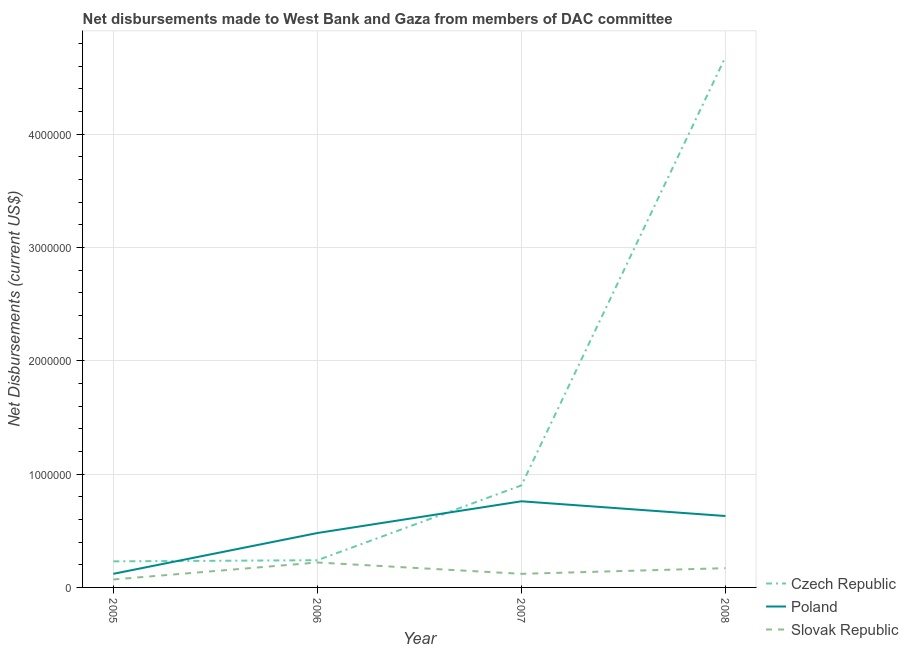How many different coloured lines are there?
Provide a succinct answer. 3. Is the number of lines equal to the number of legend labels?
Your response must be concise. Yes. What is the net disbursements made by slovak republic in 2008?
Offer a terse response. 1.70e+05. Across all years, what is the maximum net disbursements made by czech republic?
Your answer should be compact. 4.68e+06. Across all years, what is the minimum net disbursements made by slovak republic?
Give a very brief answer. 7.00e+04. In which year was the net disbursements made by czech republic maximum?
Provide a short and direct response. 2008. In which year was the net disbursements made by czech republic minimum?
Your response must be concise. 2005. What is the total net disbursements made by poland in the graph?
Provide a short and direct response. 1.99e+06. What is the difference between the net disbursements made by poland in 2005 and that in 2008?
Your answer should be very brief. -5.10e+05. What is the difference between the net disbursements made by slovak republic in 2007 and the net disbursements made by czech republic in 2006?
Ensure brevity in your answer.  -1.20e+05. What is the average net disbursements made by poland per year?
Offer a terse response. 4.98e+05. In the year 2005, what is the difference between the net disbursements made by poland and net disbursements made by slovak republic?
Provide a short and direct response. 5.00e+04. In how many years, is the net disbursements made by poland greater than 4200000 US$?
Your answer should be very brief. 0. What is the ratio of the net disbursements made by slovak republic in 2005 to that in 2008?
Your response must be concise. 0.41. Is the net disbursements made by czech republic in 2006 less than that in 2007?
Your answer should be very brief. Yes. What is the difference between the highest and the second highest net disbursements made by czech republic?
Keep it short and to the point. 3.78e+06. What is the difference between the highest and the lowest net disbursements made by slovak republic?
Make the answer very short. 1.50e+05. In how many years, is the net disbursements made by czech republic greater than the average net disbursements made by czech republic taken over all years?
Your answer should be compact. 1. Is the sum of the net disbursements made by poland in 2005 and 2008 greater than the maximum net disbursements made by slovak republic across all years?
Offer a terse response. Yes. Is it the case that in every year, the sum of the net disbursements made by czech republic and net disbursements made by poland is greater than the net disbursements made by slovak republic?
Your answer should be compact. Yes. How many lines are there?
Your response must be concise. 3. What is the difference between two consecutive major ticks on the Y-axis?
Keep it short and to the point. 1.00e+06. Are the values on the major ticks of Y-axis written in scientific E-notation?
Make the answer very short. No. Does the graph contain any zero values?
Offer a terse response. No. Where does the legend appear in the graph?
Your response must be concise. Bottom right. What is the title of the graph?
Your response must be concise. Net disbursements made to West Bank and Gaza from members of DAC committee. What is the label or title of the Y-axis?
Give a very brief answer. Net Disbursements (current US$). What is the Net Disbursements (current US$) in Slovak Republic in 2006?
Ensure brevity in your answer.  2.20e+05. What is the Net Disbursements (current US$) in Czech Republic in 2007?
Offer a very short reply. 9.00e+05. What is the Net Disbursements (current US$) of Poland in 2007?
Offer a very short reply. 7.60e+05. What is the Net Disbursements (current US$) of Slovak Republic in 2007?
Your answer should be compact. 1.20e+05. What is the Net Disbursements (current US$) of Czech Republic in 2008?
Give a very brief answer. 4.68e+06. What is the Net Disbursements (current US$) of Poland in 2008?
Keep it short and to the point. 6.30e+05. Across all years, what is the maximum Net Disbursements (current US$) in Czech Republic?
Provide a short and direct response. 4.68e+06. Across all years, what is the maximum Net Disbursements (current US$) of Poland?
Keep it short and to the point. 7.60e+05. Across all years, what is the maximum Net Disbursements (current US$) in Slovak Republic?
Offer a terse response. 2.20e+05. Across all years, what is the minimum Net Disbursements (current US$) in Czech Republic?
Your answer should be compact. 2.30e+05. Across all years, what is the minimum Net Disbursements (current US$) in Poland?
Offer a terse response. 1.20e+05. What is the total Net Disbursements (current US$) in Czech Republic in the graph?
Make the answer very short. 6.05e+06. What is the total Net Disbursements (current US$) of Poland in the graph?
Your answer should be very brief. 1.99e+06. What is the total Net Disbursements (current US$) in Slovak Republic in the graph?
Keep it short and to the point. 5.80e+05. What is the difference between the Net Disbursements (current US$) in Czech Republic in 2005 and that in 2006?
Keep it short and to the point. -10000. What is the difference between the Net Disbursements (current US$) of Poland in 2005 and that in 2006?
Keep it short and to the point. -3.60e+05. What is the difference between the Net Disbursements (current US$) in Slovak Republic in 2005 and that in 2006?
Provide a succinct answer. -1.50e+05. What is the difference between the Net Disbursements (current US$) in Czech Republic in 2005 and that in 2007?
Offer a very short reply. -6.70e+05. What is the difference between the Net Disbursements (current US$) of Poland in 2005 and that in 2007?
Offer a terse response. -6.40e+05. What is the difference between the Net Disbursements (current US$) in Czech Republic in 2005 and that in 2008?
Your answer should be very brief. -4.45e+06. What is the difference between the Net Disbursements (current US$) of Poland in 2005 and that in 2008?
Offer a terse response. -5.10e+05. What is the difference between the Net Disbursements (current US$) in Slovak Republic in 2005 and that in 2008?
Ensure brevity in your answer.  -1.00e+05. What is the difference between the Net Disbursements (current US$) in Czech Republic in 2006 and that in 2007?
Keep it short and to the point. -6.60e+05. What is the difference between the Net Disbursements (current US$) in Poland in 2006 and that in 2007?
Offer a very short reply. -2.80e+05. What is the difference between the Net Disbursements (current US$) of Slovak Republic in 2006 and that in 2007?
Offer a terse response. 1.00e+05. What is the difference between the Net Disbursements (current US$) in Czech Republic in 2006 and that in 2008?
Your answer should be very brief. -4.44e+06. What is the difference between the Net Disbursements (current US$) in Slovak Republic in 2006 and that in 2008?
Offer a terse response. 5.00e+04. What is the difference between the Net Disbursements (current US$) in Czech Republic in 2007 and that in 2008?
Keep it short and to the point. -3.78e+06. What is the difference between the Net Disbursements (current US$) in Poland in 2007 and that in 2008?
Give a very brief answer. 1.30e+05. What is the difference between the Net Disbursements (current US$) in Slovak Republic in 2007 and that in 2008?
Your response must be concise. -5.00e+04. What is the difference between the Net Disbursements (current US$) of Czech Republic in 2005 and the Net Disbursements (current US$) of Poland in 2007?
Offer a terse response. -5.30e+05. What is the difference between the Net Disbursements (current US$) of Poland in 2005 and the Net Disbursements (current US$) of Slovak Republic in 2007?
Offer a terse response. 0. What is the difference between the Net Disbursements (current US$) in Czech Republic in 2005 and the Net Disbursements (current US$) in Poland in 2008?
Keep it short and to the point. -4.00e+05. What is the difference between the Net Disbursements (current US$) in Poland in 2005 and the Net Disbursements (current US$) in Slovak Republic in 2008?
Provide a succinct answer. -5.00e+04. What is the difference between the Net Disbursements (current US$) of Czech Republic in 2006 and the Net Disbursements (current US$) of Poland in 2007?
Offer a terse response. -5.20e+05. What is the difference between the Net Disbursements (current US$) of Poland in 2006 and the Net Disbursements (current US$) of Slovak Republic in 2007?
Offer a very short reply. 3.60e+05. What is the difference between the Net Disbursements (current US$) in Czech Republic in 2006 and the Net Disbursements (current US$) in Poland in 2008?
Your answer should be very brief. -3.90e+05. What is the difference between the Net Disbursements (current US$) of Czech Republic in 2007 and the Net Disbursements (current US$) of Poland in 2008?
Your answer should be compact. 2.70e+05. What is the difference between the Net Disbursements (current US$) in Czech Republic in 2007 and the Net Disbursements (current US$) in Slovak Republic in 2008?
Provide a succinct answer. 7.30e+05. What is the difference between the Net Disbursements (current US$) of Poland in 2007 and the Net Disbursements (current US$) of Slovak Republic in 2008?
Offer a terse response. 5.90e+05. What is the average Net Disbursements (current US$) in Czech Republic per year?
Offer a very short reply. 1.51e+06. What is the average Net Disbursements (current US$) in Poland per year?
Your answer should be very brief. 4.98e+05. What is the average Net Disbursements (current US$) in Slovak Republic per year?
Offer a terse response. 1.45e+05. In the year 2005, what is the difference between the Net Disbursements (current US$) of Czech Republic and Net Disbursements (current US$) of Slovak Republic?
Give a very brief answer. 1.60e+05. In the year 2006, what is the difference between the Net Disbursements (current US$) in Czech Republic and Net Disbursements (current US$) in Poland?
Make the answer very short. -2.40e+05. In the year 2006, what is the difference between the Net Disbursements (current US$) of Czech Republic and Net Disbursements (current US$) of Slovak Republic?
Make the answer very short. 2.00e+04. In the year 2007, what is the difference between the Net Disbursements (current US$) in Czech Republic and Net Disbursements (current US$) in Slovak Republic?
Offer a very short reply. 7.80e+05. In the year 2007, what is the difference between the Net Disbursements (current US$) of Poland and Net Disbursements (current US$) of Slovak Republic?
Your response must be concise. 6.40e+05. In the year 2008, what is the difference between the Net Disbursements (current US$) of Czech Republic and Net Disbursements (current US$) of Poland?
Make the answer very short. 4.05e+06. In the year 2008, what is the difference between the Net Disbursements (current US$) in Czech Republic and Net Disbursements (current US$) in Slovak Republic?
Offer a terse response. 4.51e+06. What is the ratio of the Net Disbursements (current US$) in Czech Republic in 2005 to that in 2006?
Your answer should be very brief. 0.96. What is the ratio of the Net Disbursements (current US$) in Poland in 2005 to that in 2006?
Ensure brevity in your answer.  0.25. What is the ratio of the Net Disbursements (current US$) in Slovak Republic in 2005 to that in 2006?
Offer a very short reply. 0.32. What is the ratio of the Net Disbursements (current US$) in Czech Republic in 2005 to that in 2007?
Provide a short and direct response. 0.26. What is the ratio of the Net Disbursements (current US$) of Poland in 2005 to that in 2007?
Provide a short and direct response. 0.16. What is the ratio of the Net Disbursements (current US$) in Slovak Republic in 2005 to that in 2007?
Provide a succinct answer. 0.58. What is the ratio of the Net Disbursements (current US$) in Czech Republic in 2005 to that in 2008?
Make the answer very short. 0.05. What is the ratio of the Net Disbursements (current US$) in Poland in 2005 to that in 2008?
Your answer should be very brief. 0.19. What is the ratio of the Net Disbursements (current US$) in Slovak Republic in 2005 to that in 2008?
Offer a very short reply. 0.41. What is the ratio of the Net Disbursements (current US$) in Czech Republic in 2006 to that in 2007?
Your answer should be compact. 0.27. What is the ratio of the Net Disbursements (current US$) in Poland in 2006 to that in 2007?
Give a very brief answer. 0.63. What is the ratio of the Net Disbursements (current US$) in Slovak Republic in 2006 to that in 2007?
Provide a succinct answer. 1.83. What is the ratio of the Net Disbursements (current US$) of Czech Republic in 2006 to that in 2008?
Your answer should be compact. 0.05. What is the ratio of the Net Disbursements (current US$) of Poland in 2006 to that in 2008?
Keep it short and to the point. 0.76. What is the ratio of the Net Disbursements (current US$) in Slovak Republic in 2006 to that in 2008?
Give a very brief answer. 1.29. What is the ratio of the Net Disbursements (current US$) of Czech Republic in 2007 to that in 2008?
Keep it short and to the point. 0.19. What is the ratio of the Net Disbursements (current US$) of Poland in 2007 to that in 2008?
Offer a very short reply. 1.21. What is the ratio of the Net Disbursements (current US$) in Slovak Republic in 2007 to that in 2008?
Ensure brevity in your answer.  0.71. What is the difference between the highest and the second highest Net Disbursements (current US$) in Czech Republic?
Your response must be concise. 3.78e+06. What is the difference between the highest and the lowest Net Disbursements (current US$) in Czech Republic?
Provide a succinct answer. 4.45e+06. What is the difference between the highest and the lowest Net Disbursements (current US$) in Poland?
Keep it short and to the point. 6.40e+05. 